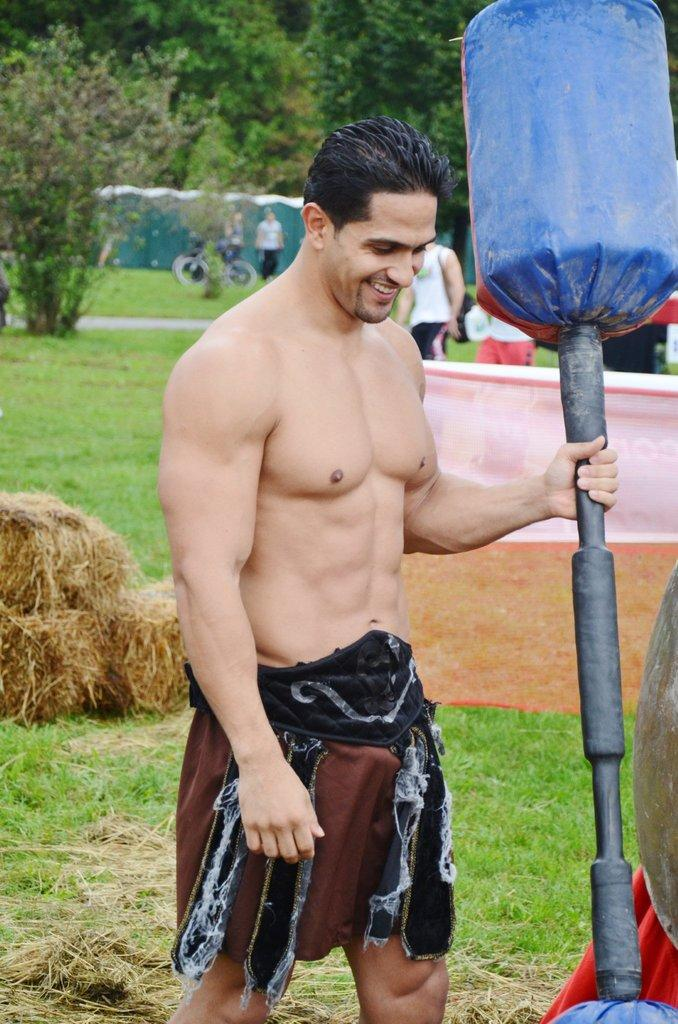What is the man in the image holding? The man is holding a dumbbell. What is the man's facial expression in the image? The man is smiling. What type of surface is visible in the image? There is grass in the image. What other types of vegetation can be seen in the image? There are plants in the image. Can you describe the background of the image? There are people and trees in the background of the image. What shape is the cork in the image? There is no cork present in the image. What trick is the man performing with the dumbbell in the image? The image does not depict the man performing any tricks with the dumbbell; he is simply holding it. 